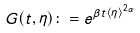<formula> <loc_0><loc_0><loc_500><loc_500>G ( t , \eta ) \colon = e ^ { \beta t \langle \eta \rangle ^ { 2 \alpha } }</formula> 